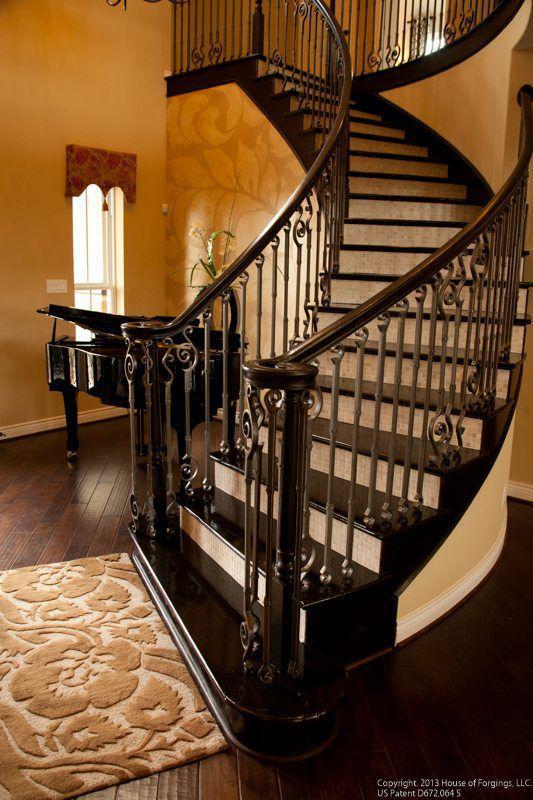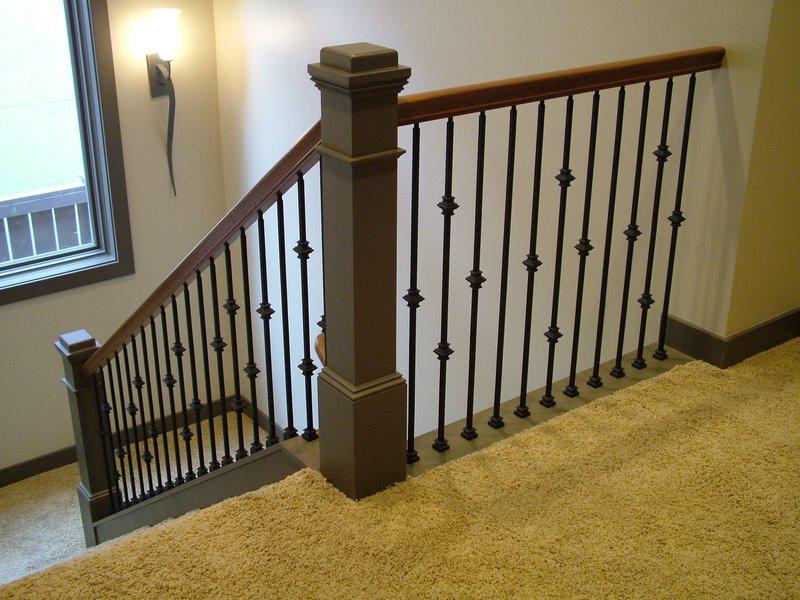The first image is the image on the left, the second image is the image on the right. Given the left and right images, does the statement "One of the stairways curves, while the other stairway has straight sections." hold true? Answer yes or no. Yes. The first image is the image on the left, the second image is the image on the right. For the images displayed, is the sentence "Each image features a non-curved staircase with wooden handrails and wrought iron bars that feature some dimensional decorative element." factually correct? Answer yes or no. No. 